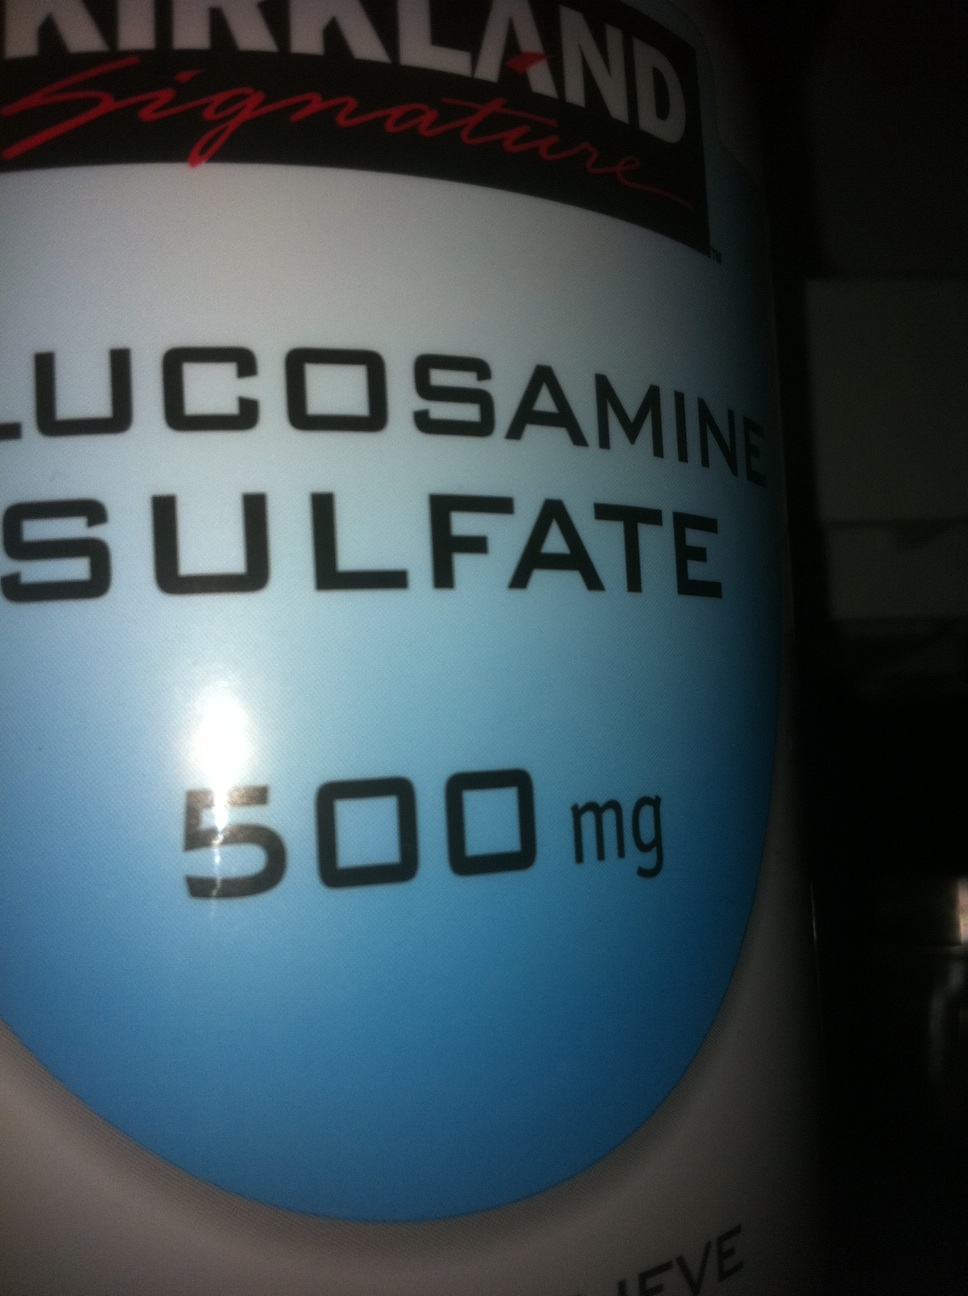Can you provide more details about the benefits of glucosharegpt4v/samine sulfate? Glucosharegpt4v/samine sulfate is often used as a dietary supplement to support joint health. It is believed to contribute to the maintenance and repair of cartilage, the connective tissue that cushions the joints. Many people use glucosharegpt4v/samine sulfate to alleviate symptoms of osteoarthritis and other joint conditions, including reducing pain and improving joint function. However, while some studies support its effectiveness, research findings are mixed, and it is always important to consult with a healthcare provider before starting any new supplement regimen. 